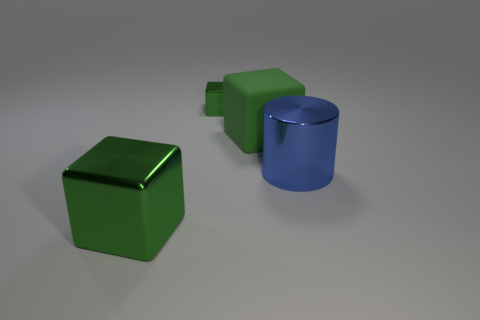Does the large thing that is behind the blue cylinder have the same material as the tiny green block?
Your answer should be compact. No. What is the material of the large green block that is on the right side of the large metal thing that is in front of the blue metallic cylinder?
Provide a short and direct response. Rubber. Are there more green blocks that are in front of the small green block than green objects left of the green matte block?
Ensure brevity in your answer.  No. The matte thing has what size?
Your answer should be compact. Large. There is a large object that is to the left of the large green rubber object; is its color the same as the big matte thing?
Make the answer very short. Yes. Is there anything else that is the same shape as the large blue thing?
Your response must be concise. No. Is there a green rubber block that is behind the large metallic thing that is to the right of the green rubber cube?
Make the answer very short. Yes. Are there fewer tiny metal cubes in front of the large blue metal thing than big green things to the left of the rubber cube?
Your answer should be compact. Yes. There is a green cube in front of the big metal object that is behind the big green cube that is on the left side of the green matte block; what size is it?
Give a very brief answer. Large. Do the shiny cube that is behind the blue shiny object and the blue thing have the same size?
Ensure brevity in your answer.  No. 